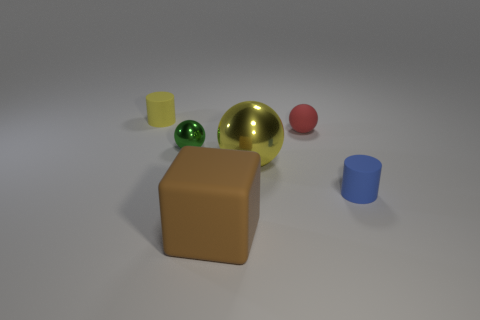The matte block is what color?
Offer a very short reply. Brown. Is the color of the thing that is in front of the blue cylinder the same as the small sphere in front of the small red matte thing?
Keep it short and to the point. No. What size is the green thing that is the same shape as the large yellow thing?
Provide a succinct answer. Small. Are there any small shiny spheres of the same color as the large matte thing?
Your response must be concise. No. What is the material of the cylinder that is the same color as the big metal sphere?
Make the answer very short. Rubber. How many rubber objects are the same color as the rubber ball?
Keep it short and to the point. 0. What number of objects are tiny matte cylinders right of the yellow rubber object or large brown blocks?
Your response must be concise. 2. What is the color of the block that is made of the same material as the red ball?
Your answer should be compact. Brown. Is there a matte cube that has the same size as the blue matte cylinder?
Your answer should be very brief. No. How many objects are either cylinders that are to the left of the blue rubber cylinder or tiny objects that are to the right of the small yellow rubber cylinder?
Make the answer very short. 4. 